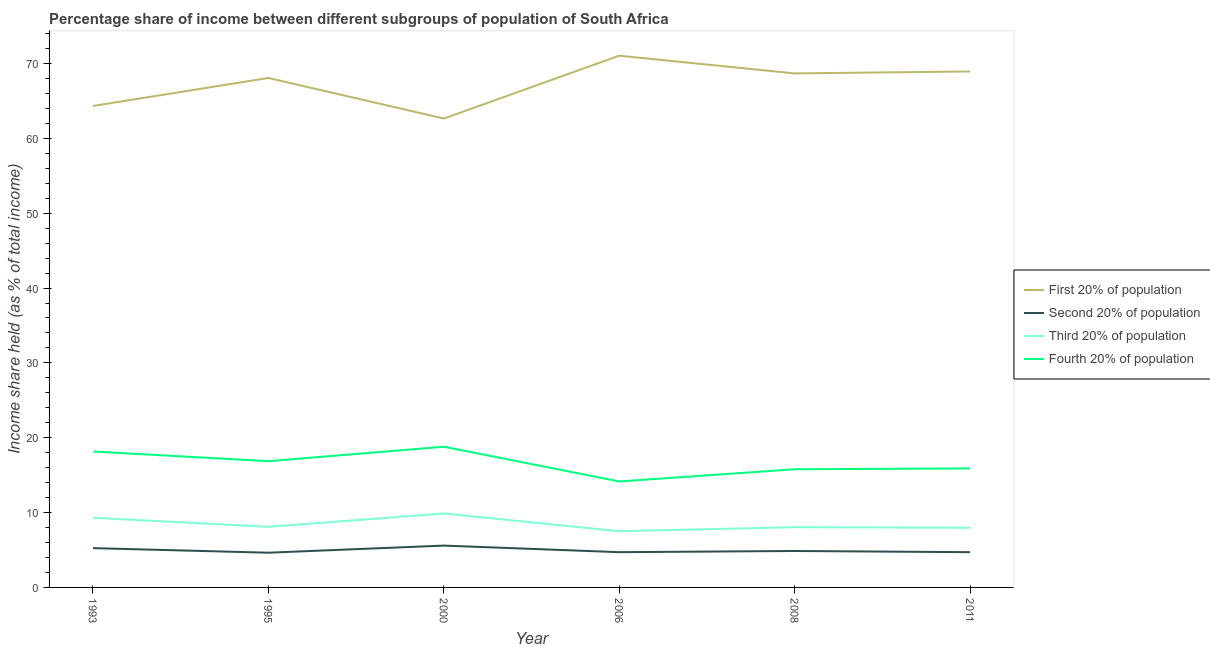Does the line corresponding to share of the income held by second 20% of the population intersect with the line corresponding to share of the income held by first 20% of the population?
Offer a very short reply. No. What is the share of the income held by first 20% of the population in 2011?
Make the answer very short. 68.94. Across all years, what is the maximum share of the income held by third 20% of the population?
Offer a terse response. 9.88. Across all years, what is the minimum share of the income held by third 20% of the population?
Offer a very short reply. 7.51. In which year was the share of the income held by fourth 20% of the population minimum?
Keep it short and to the point. 2006. What is the total share of the income held by third 20% of the population in the graph?
Your response must be concise. 50.82. What is the difference between the share of the income held by second 20% of the population in 2000 and that in 2008?
Your answer should be compact. 0.72. What is the difference between the share of the income held by first 20% of the population in 1995 and the share of the income held by second 20% of the population in 2008?
Offer a very short reply. 63.2. What is the average share of the income held by fourth 20% of the population per year?
Provide a succinct answer. 16.61. In the year 1995, what is the difference between the share of the income held by third 20% of the population and share of the income held by second 20% of the population?
Your response must be concise. 3.46. In how many years, is the share of the income held by second 20% of the population greater than 46 %?
Provide a succinct answer. 0. What is the ratio of the share of the income held by third 20% of the population in 1995 to that in 2011?
Make the answer very short. 1.02. Is the share of the income held by first 20% of the population in 1993 less than that in 2011?
Keep it short and to the point. Yes. What is the difference between the highest and the second highest share of the income held by third 20% of the population?
Your answer should be very brief. 0.57. What is the difference between the highest and the lowest share of the income held by second 20% of the population?
Offer a terse response. 0.95. Is the sum of the share of the income held by fourth 20% of the population in 2000 and 2011 greater than the maximum share of the income held by second 20% of the population across all years?
Provide a short and direct response. Yes. Is it the case that in every year, the sum of the share of the income held by first 20% of the population and share of the income held by second 20% of the population is greater than the share of the income held by third 20% of the population?
Keep it short and to the point. Yes. Is the share of the income held by third 20% of the population strictly greater than the share of the income held by second 20% of the population over the years?
Your answer should be very brief. Yes. How many years are there in the graph?
Your answer should be very brief. 6. How are the legend labels stacked?
Offer a terse response. Vertical. What is the title of the graph?
Your answer should be very brief. Percentage share of income between different subgroups of population of South Africa. What is the label or title of the Y-axis?
Give a very brief answer. Income share held (as % of total income). What is the Income share held (as % of total income) of First 20% of population in 1993?
Make the answer very short. 64.33. What is the Income share held (as % of total income) of Second 20% of population in 1993?
Give a very brief answer. 5.25. What is the Income share held (as % of total income) in Third 20% of population in 1993?
Your answer should be compact. 9.31. What is the Income share held (as % of total income) in Fourth 20% of population in 1993?
Provide a short and direct response. 18.16. What is the Income share held (as % of total income) of First 20% of population in 1995?
Ensure brevity in your answer.  68.07. What is the Income share held (as % of total income) in Second 20% of population in 1995?
Your response must be concise. 4.64. What is the Income share held (as % of total income) of Third 20% of population in 1995?
Keep it short and to the point. 8.1. What is the Income share held (as % of total income) in Fourth 20% of population in 1995?
Keep it short and to the point. 16.87. What is the Income share held (as % of total income) of First 20% of population in 2000?
Your answer should be very brief. 62.65. What is the Income share held (as % of total income) of Second 20% of population in 2000?
Offer a terse response. 5.59. What is the Income share held (as % of total income) of Third 20% of population in 2000?
Provide a short and direct response. 9.88. What is the Income share held (as % of total income) in Fourth 20% of population in 2000?
Make the answer very short. 18.8. What is the Income share held (as % of total income) of First 20% of population in 2006?
Offer a very short reply. 71.05. What is the Income share held (as % of total income) in Second 20% of population in 2006?
Provide a short and direct response. 4.71. What is the Income share held (as % of total income) in Third 20% of population in 2006?
Offer a very short reply. 7.51. What is the Income share held (as % of total income) of Fourth 20% of population in 2006?
Your answer should be compact. 14.16. What is the Income share held (as % of total income) in First 20% of population in 2008?
Provide a short and direct response. 68.68. What is the Income share held (as % of total income) in Second 20% of population in 2008?
Ensure brevity in your answer.  4.87. What is the Income share held (as % of total income) in Third 20% of population in 2008?
Offer a terse response. 8.05. What is the Income share held (as % of total income) in Fourth 20% of population in 2008?
Provide a short and direct response. 15.79. What is the Income share held (as % of total income) of First 20% of population in 2011?
Your response must be concise. 68.94. What is the Income share held (as % of total income) in Second 20% of population in 2011?
Offer a terse response. 4.71. What is the Income share held (as % of total income) of Third 20% of population in 2011?
Keep it short and to the point. 7.97. Across all years, what is the maximum Income share held (as % of total income) in First 20% of population?
Your response must be concise. 71.05. Across all years, what is the maximum Income share held (as % of total income) in Second 20% of population?
Ensure brevity in your answer.  5.59. Across all years, what is the maximum Income share held (as % of total income) in Third 20% of population?
Make the answer very short. 9.88. Across all years, what is the maximum Income share held (as % of total income) in Fourth 20% of population?
Offer a terse response. 18.8. Across all years, what is the minimum Income share held (as % of total income) in First 20% of population?
Ensure brevity in your answer.  62.65. Across all years, what is the minimum Income share held (as % of total income) in Second 20% of population?
Keep it short and to the point. 4.64. Across all years, what is the minimum Income share held (as % of total income) of Third 20% of population?
Your answer should be compact. 7.51. Across all years, what is the minimum Income share held (as % of total income) in Fourth 20% of population?
Keep it short and to the point. 14.16. What is the total Income share held (as % of total income) of First 20% of population in the graph?
Keep it short and to the point. 403.72. What is the total Income share held (as % of total income) in Second 20% of population in the graph?
Your response must be concise. 29.77. What is the total Income share held (as % of total income) in Third 20% of population in the graph?
Provide a short and direct response. 50.82. What is the total Income share held (as % of total income) of Fourth 20% of population in the graph?
Ensure brevity in your answer.  99.68. What is the difference between the Income share held (as % of total income) in First 20% of population in 1993 and that in 1995?
Make the answer very short. -3.74. What is the difference between the Income share held (as % of total income) in Second 20% of population in 1993 and that in 1995?
Offer a very short reply. 0.61. What is the difference between the Income share held (as % of total income) in Third 20% of population in 1993 and that in 1995?
Your answer should be compact. 1.21. What is the difference between the Income share held (as % of total income) in Fourth 20% of population in 1993 and that in 1995?
Make the answer very short. 1.29. What is the difference between the Income share held (as % of total income) in First 20% of population in 1993 and that in 2000?
Give a very brief answer. 1.68. What is the difference between the Income share held (as % of total income) of Second 20% of population in 1993 and that in 2000?
Your answer should be compact. -0.34. What is the difference between the Income share held (as % of total income) in Third 20% of population in 1993 and that in 2000?
Keep it short and to the point. -0.57. What is the difference between the Income share held (as % of total income) of Fourth 20% of population in 1993 and that in 2000?
Offer a very short reply. -0.64. What is the difference between the Income share held (as % of total income) of First 20% of population in 1993 and that in 2006?
Provide a succinct answer. -6.72. What is the difference between the Income share held (as % of total income) of Second 20% of population in 1993 and that in 2006?
Your response must be concise. 0.54. What is the difference between the Income share held (as % of total income) in Fourth 20% of population in 1993 and that in 2006?
Make the answer very short. 4. What is the difference between the Income share held (as % of total income) of First 20% of population in 1993 and that in 2008?
Your response must be concise. -4.35. What is the difference between the Income share held (as % of total income) in Second 20% of population in 1993 and that in 2008?
Give a very brief answer. 0.38. What is the difference between the Income share held (as % of total income) of Third 20% of population in 1993 and that in 2008?
Your response must be concise. 1.26. What is the difference between the Income share held (as % of total income) in Fourth 20% of population in 1993 and that in 2008?
Ensure brevity in your answer.  2.37. What is the difference between the Income share held (as % of total income) of First 20% of population in 1993 and that in 2011?
Give a very brief answer. -4.61. What is the difference between the Income share held (as % of total income) in Second 20% of population in 1993 and that in 2011?
Give a very brief answer. 0.54. What is the difference between the Income share held (as % of total income) of Third 20% of population in 1993 and that in 2011?
Your answer should be very brief. 1.34. What is the difference between the Income share held (as % of total income) of Fourth 20% of population in 1993 and that in 2011?
Provide a short and direct response. 2.26. What is the difference between the Income share held (as % of total income) of First 20% of population in 1995 and that in 2000?
Provide a short and direct response. 5.42. What is the difference between the Income share held (as % of total income) of Second 20% of population in 1995 and that in 2000?
Offer a very short reply. -0.95. What is the difference between the Income share held (as % of total income) in Third 20% of population in 1995 and that in 2000?
Your response must be concise. -1.78. What is the difference between the Income share held (as % of total income) of Fourth 20% of population in 1995 and that in 2000?
Give a very brief answer. -1.93. What is the difference between the Income share held (as % of total income) of First 20% of population in 1995 and that in 2006?
Keep it short and to the point. -2.98. What is the difference between the Income share held (as % of total income) in Second 20% of population in 1995 and that in 2006?
Provide a short and direct response. -0.07. What is the difference between the Income share held (as % of total income) of Third 20% of population in 1995 and that in 2006?
Give a very brief answer. 0.59. What is the difference between the Income share held (as % of total income) in Fourth 20% of population in 1995 and that in 2006?
Your answer should be compact. 2.71. What is the difference between the Income share held (as % of total income) of First 20% of population in 1995 and that in 2008?
Your response must be concise. -0.61. What is the difference between the Income share held (as % of total income) in Second 20% of population in 1995 and that in 2008?
Offer a terse response. -0.23. What is the difference between the Income share held (as % of total income) in Third 20% of population in 1995 and that in 2008?
Ensure brevity in your answer.  0.05. What is the difference between the Income share held (as % of total income) in First 20% of population in 1995 and that in 2011?
Your answer should be compact. -0.87. What is the difference between the Income share held (as % of total income) of Second 20% of population in 1995 and that in 2011?
Keep it short and to the point. -0.07. What is the difference between the Income share held (as % of total income) of Third 20% of population in 1995 and that in 2011?
Provide a succinct answer. 0.13. What is the difference between the Income share held (as % of total income) of Second 20% of population in 2000 and that in 2006?
Provide a succinct answer. 0.88. What is the difference between the Income share held (as % of total income) in Third 20% of population in 2000 and that in 2006?
Your answer should be compact. 2.37. What is the difference between the Income share held (as % of total income) in Fourth 20% of population in 2000 and that in 2006?
Give a very brief answer. 4.64. What is the difference between the Income share held (as % of total income) in First 20% of population in 2000 and that in 2008?
Give a very brief answer. -6.03. What is the difference between the Income share held (as % of total income) in Second 20% of population in 2000 and that in 2008?
Make the answer very short. 0.72. What is the difference between the Income share held (as % of total income) of Third 20% of population in 2000 and that in 2008?
Provide a succinct answer. 1.83. What is the difference between the Income share held (as % of total income) in Fourth 20% of population in 2000 and that in 2008?
Your response must be concise. 3.01. What is the difference between the Income share held (as % of total income) of First 20% of population in 2000 and that in 2011?
Your answer should be very brief. -6.29. What is the difference between the Income share held (as % of total income) in Second 20% of population in 2000 and that in 2011?
Ensure brevity in your answer.  0.88. What is the difference between the Income share held (as % of total income) in Third 20% of population in 2000 and that in 2011?
Keep it short and to the point. 1.91. What is the difference between the Income share held (as % of total income) in Fourth 20% of population in 2000 and that in 2011?
Your answer should be compact. 2.9. What is the difference between the Income share held (as % of total income) of First 20% of population in 2006 and that in 2008?
Your response must be concise. 2.37. What is the difference between the Income share held (as % of total income) of Second 20% of population in 2006 and that in 2008?
Your answer should be very brief. -0.16. What is the difference between the Income share held (as % of total income) of Third 20% of population in 2006 and that in 2008?
Make the answer very short. -0.54. What is the difference between the Income share held (as % of total income) in Fourth 20% of population in 2006 and that in 2008?
Offer a terse response. -1.63. What is the difference between the Income share held (as % of total income) in First 20% of population in 2006 and that in 2011?
Make the answer very short. 2.11. What is the difference between the Income share held (as % of total income) of Third 20% of population in 2006 and that in 2011?
Your answer should be compact. -0.46. What is the difference between the Income share held (as % of total income) in Fourth 20% of population in 2006 and that in 2011?
Provide a short and direct response. -1.74. What is the difference between the Income share held (as % of total income) of First 20% of population in 2008 and that in 2011?
Keep it short and to the point. -0.26. What is the difference between the Income share held (as % of total income) in Second 20% of population in 2008 and that in 2011?
Make the answer very short. 0.16. What is the difference between the Income share held (as % of total income) in Fourth 20% of population in 2008 and that in 2011?
Offer a very short reply. -0.11. What is the difference between the Income share held (as % of total income) of First 20% of population in 1993 and the Income share held (as % of total income) of Second 20% of population in 1995?
Provide a short and direct response. 59.69. What is the difference between the Income share held (as % of total income) in First 20% of population in 1993 and the Income share held (as % of total income) in Third 20% of population in 1995?
Provide a short and direct response. 56.23. What is the difference between the Income share held (as % of total income) of First 20% of population in 1993 and the Income share held (as % of total income) of Fourth 20% of population in 1995?
Offer a terse response. 47.46. What is the difference between the Income share held (as % of total income) in Second 20% of population in 1993 and the Income share held (as % of total income) in Third 20% of population in 1995?
Offer a very short reply. -2.85. What is the difference between the Income share held (as % of total income) in Second 20% of population in 1993 and the Income share held (as % of total income) in Fourth 20% of population in 1995?
Make the answer very short. -11.62. What is the difference between the Income share held (as % of total income) of Third 20% of population in 1993 and the Income share held (as % of total income) of Fourth 20% of population in 1995?
Your response must be concise. -7.56. What is the difference between the Income share held (as % of total income) of First 20% of population in 1993 and the Income share held (as % of total income) of Second 20% of population in 2000?
Offer a terse response. 58.74. What is the difference between the Income share held (as % of total income) in First 20% of population in 1993 and the Income share held (as % of total income) in Third 20% of population in 2000?
Provide a short and direct response. 54.45. What is the difference between the Income share held (as % of total income) in First 20% of population in 1993 and the Income share held (as % of total income) in Fourth 20% of population in 2000?
Give a very brief answer. 45.53. What is the difference between the Income share held (as % of total income) in Second 20% of population in 1993 and the Income share held (as % of total income) in Third 20% of population in 2000?
Keep it short and to the point. -4.63. What is the difference between the Income share held (as % of total income) in Second 20% of population in 1993 and the Income share held (as % of total income) in Fourth 20% of population in 2000?
Your answer should be very brief. -13.55. What is the difference between the Income share held (as % of total income) of Third 20% of population in 1993 and the Income share held (as % of total income) of Fourth 20% of population in 2000?
Your answer should be compact. -9.49. What is the difference between the Income share held (as % of total income) of First 20% of population in 1993 and the Income share held (as % of total income) of Second 20% of population in 2006?
Give a very brief answer. 59.62. What is the difference between the Income share held (as % of total income) in First 20% of population in 1993 and the Income share held (as % of total income) in Third 20% of population in 2006?
Your answer should be very brief. 56.82. What is the difference between the Income share held (as % of total income) of First 20% of population in 1993 and the Income share held (as % of total income) of Fourth 20% of population in 2006?
Your answer should be compact. 50.17. What is the difference between the Income share held (as % of total income) of Second 20% of population in 1993 and the Income share held (as % of total income) of Third 20% of population in 2006?
Provide a short and direct response. -2.26. What is the difference between the Income share held (as % of total income) in Second 20% of population in 1993 and the Income share held (as % of total income) in Fourth 20% of population in 2006?
Your response must be concise. -8.91. What is the difference between the Income share held (as % of total income) in Third 20% of population in 1993 and the Income share held (as % of total income) in Fourth 20% of population in 2006?
Offer a terse response. -4.85. What is the difference between the Income share held (as % of total income) of First 20% of population in 1993 and the Income share held (as % of total income) of Second 20% of population in 2008?
Provide a short and direct response. 59.46. What is the difference between the Income share held (as % of total income) of First 20% of population in 1993 and the Income share held (as % of total income) of Third 20% of population in 2008?
Offer a very short reply. 56.28. What is the difference between the Income share held (as % of total income) of First 20% of population in 1993 and the Income share held (as % of total income) of Fourth 20% of population in 2008?
Offer a very short reply. 48.54. What is the difference between the Income share held (as % of total income) of Second 20% of population in 1993 and the Income share held (as % of total income) of Third 20% of population in 2008?
Your answer should be very brief. -2.8. What is the difference between the Income share held (as % of total income) of Second 20% of population in 1993 and the Income share held (as % of total income) of Fourth 20% of population in 2008?
Your response must be concise. -10.54. What is the difference between the Income share held (as % of total income) in Third 20% of population in 1993 and the Income share held (as % of total income) in Fourth 20% of population in 2008?
Offer a terse response. -6.48. What is the difference between the Income share held (as % of total income) of First 20% of population in 1993 and the Income share held (as % of total income) of Second 20% of population in 2011?
Provide a succinct answer. 59.62. What is the difference between the Income share held (as % of total income) of First 20% of population in 1993 and the Income share held (as % of total income) of Third 20% of population in 2011?
Offer a very short reply. 56.36. What is the difference between the Income share held (as % of total income) of First 20% of population in 1993 and the Income share held (as % of total income) of Fourth 20% of population in 2011?
Offer a very short reply. 48.43. What is the difference between the Income share held (as % of total income) in Second 20% of population in 1993 and the Income share held (as % of total income) in Third 20% of population in 2011?
Provide a succinct answer. -2.72. What is the difference between the Income share held (as % of total income) of Second 20% of population in 1993 and the Income share held (as % of total income) of Fourth 20% of population in 2011?
Your answer should be very brief. -10.65. What is the difference between the Income share held (as % of total income) in Third 20% of population in 1993 and the Income share held (as % of total income) in Fourth 20% of population in 2011?
Keep it short and to the point. -6.59. What is the difference between the Income share held (as % of total income) of First 20% of population in 1995 and the Income share held (as % of total income) of Second 20% of population in 2000?
Offer a terse response. 62.48. What is the difference between the Income share held (as % of total income) in First 20% of population in 1995 and the Income share held (as % of total income) in Third 20% of population in 2000?
Provide a succinct answer. 58.19. What is the difference between the Income share held (as % of total income) of First 20% of population in 1995 and the Income share held (as % of total income) of Fourth 20% of population in 2000?
Your answer should be compact. 49.27. What is the difference between the Income share held (as % of total income) in Second 20% of population in 1995 and the Income share held (as % of total income) in Third 20% of population in 2000?
Ensure brevity in your answer.  -5.24. What is the difference between the Income share held (as % of total income) of Second 20% of population in 1995 and the Income share held (as % of total income) of Fourth 20% of population in 2000?
Provide a short and direct response. -14.16. What is the difference between the Income share held (as % of total income) in First 20% of population in 1995 and the Income share held (as % of total income) in Second 20% of population in 2006?
Provide a short and direct response. 63.36. What is the difference between the Income share held (as % of total income) in First 20% of population in 1995 and the Income share held (as % of total income) in Third 20% of population in 2006?
Offer a very short reply. 60.56. What is the difference between the Income share held (as % of total income) in First 20% of population in 1995 and the Income share held (as % of total income) in Fourth 20% of population in 2006?
Your answer should be very brief. 53.91. What is the difference between the Income share held (as % of total income) in Second 20% of population in 1995 and the Income share held (as % of total income) in Third 20% of population in 2006?
Ensure brevity in your answer.  -2.87. What is the difference between the Income share held (as % of total income) of Second 20% of population in 1995 and the Income share held (as % of total income) of Fourth 20% of population in 2006?
Make the answer very short. -9.52. What is the difference between the Income share held (as % of total income) of Third 20% of population in 1995 and the Income share held (as % of total income) of Fourth 20% of population in 2006?
Provide a succinct answer. -6.06. What is the difference between the Income share held (as % of total income) of First 20% of population in 1995 and the Income share held (as % of total income) of Second 20% of population in 2008?
Offer a terse response. 63.2. What is the difference between the Income share held (as % of total income) in First 20% of population in 1995 and the Income share held (as % of total income) in Third 20% of population in 2008?
Keep it short and to the point. 60.02. What is the difference between the Income share held (as % of total income) in First 20% of population in 1995 and the Income share held (as % of total income) in Fourth 20% of population in 2008?
Your answer should be compact. 52.28. What is the difference between the Income share held (as % of total income) of Second 20% of population in 1995 and the Income share held (as % of total income) of Third 20% of population in 2008?
Your answer should be very brief. -3.41. What is the difference between the Income share held (as % of total income) of Second 20% of population in 1995 and the Income share held (as % of total income) of Fourth 20% of population in 2008?
Offer a terse response. -11.15. What is the difference between the Income share held (as % of total income) in Third 20% of population in 1995 and the Income share held (as % of total income) in Fourth 20% of population in 2008?
Give a very brief answer. -7.69. What is the difference between the Income share held (as % of total income) of First 20% of population in 1995 and the Income share held (as % of total income) of Second 20% of population in 2011?
Keep it short and to the point. 63.36. What is the difference between the Income share held (as % of total income) of First 20% of population in 1995 and the Income share held (as % of total income) of Third 20% of population in 2011?
Keep it short and to the point. 60.1. What is the difference between the Income share held (as % of total income) of First 20% of population in 1995 and the Income share held (as % of total income) of Fourth 20% of population in 2011?
Your answer should be very brief. 52.17. What is the difference between the Income share held (as % of total income) of Second 20% of population in 1995 and the Income share held (as % of total income) of Third 20% of population in 2011?
Ensure brevity in your answer.  -3.33. What is the difference between the Income share held (as % of total income) of Second 20% of population in 1995 and the Income share held (as % of total income) of Fourth 20% of population in 2011?
Keep it short and to the point. -11.26. What is the difference between the Income share held (as % of total income) of First 20% of population in 2000 and the Income share held (as % of total income) of Second 20% of population in 2006?
Make the answer very short. 57.94. What is the difference between the Income share held (as % of total income) in First 20% of population in 2000 and the Income share held (as % of total income) in Third 20% of population in 2006?
Your answer should be very brief. 55.14. What is the difference between the Income share held (as % of total income) of First 20% of population in 2000 and the Income share held (as % of total income) of Fourth 20% of population in 2006?
Your answer should be compact. 48.49. What is the difference between the Income share held (as % of total income) in Second 20% of population in 2000 and the Income share held (as % of total income) in Third 20% of population in 2006?
Your answer should be very brief. -1.92. What is the difference between the Income share held (as % of total income) in Second 20% of population in 2000 and the Income share held (as % of total income) in Fourth 20% of population in 2006?
Your answer should be compact. -8.57. What is the difference between the Income share held (as % of total income) in Third 20% of population in 2000 and the Income share held (as % of total income) in Fourth 20% of population in 2006?
Your answer should be compact. -4.28. What is the difference between the Income share held (as % of total income) in First 20% of population in 2000 and the Income share held (as % of total income) in Second 20% of population in 2008?
Keep it short and to the point. 57.78. What is the difference between the Income share held (as % of total income) in First 20% of population in 2000 and the Income share held (as % of total income) in Third 20% of population in 2008?
Your answer should be compact. 54.6. What is the difference between the Income share held (as % of total income) of First 20% of population in 2000 and the Income share held (as % of total income) of Fourth 20% of population in 2008?
Provide a short and direct response. 46.86. What is the difference between the Income share held (as % of total income) of Second 20% of population in 2000 and the Income share held (as % of total income) of Third 20% of population in 2008?
Offer a terse response. -2.46. What is the difference between the Income share held (as % of total income) of Second 20% of population in 2000 and the Income share held (as % of total income) of Fourth 20% of population in 2008?
Offer a very short reply. -10.2. What is the difference between the Income share held (as % of total income) of Third 20% of population in 2000 and the Income share held (as % of total income) of Fourth 20% of population in 2008?
Make the answer very short. -5.91. What is the difference between the Income share held (as % of total income) of First 20% of population in 2000 and the Income share held (as % of total income) of Second 20% of population in 2011?
Provide a succinct answer. 57.94. What is the difference between the Income share held (as % of total income) in First 20% of population in 2000 and the Income share held (as % of total income) in Third 20% of population in 2011?
Offer a very short reply. 54.68. What is the difference between the Income share held (as % of total income) of First 20% of population in 2000 and the Income share held (as % of total income) of Fourth 20% of population in 2011?
Keep it short and to the point. 46.75. What is the difference between the Income share held (as % of total income) in Second 20% of population in 2000 and the Income share held (as % of total income) in Third 20% of population in 2011?
Your answer should be compact. -2.38. What is the difference between the Income share held (as % of total income) in Second 20% of population in 2000 and the Income share held (as % of total income) in Fourth 20% of population in 2011?
Keep it short and to the point. -10.31. What is the difference between the Income share held (as % of total income) in Third 20% of population in 2000 and the Income share held (as % of total income) in Fourth 20% of population in 2011?
Your answer should be compact. -6.02. What is the difference between the Income share held (as % of total income) in First 20% of population in 2006 and the Income share held (as % of total income) in Second 20% of population in 2008?
Your answer should be very brief. 66.18. What is the difference between the Income share held (as % of total income) in First 20% of population in 2006 and the Income share held (as % of total income) in Third 20% of population in 2008?
Keep it short and to the point. 63. What is the difference between the Income share held (as % of total income) of First 20% of population in 2006 and the Income share held (as % of total income) of Fourth 20% of population in 2008?
Keep it short and to the point. 55.26. What is the difference between the Income share held (as % of total income) in Second 20% of population in 2006 and the Income share held (as % of total income) in Third 20% of population in 2008?
Provide a short and direct response. -3.34. What is the difference between the Income share held (as % of total income) in Second 20% of population in 2006 and the Income share held (as % of total income) in Fourth 20% of population in 2008?
Your answer should be compact. -11.08. What is the difference between the Income share held (as % of total income) of Third 20% of population in 2006 and the Income share held (as % of total income) of Fourth 20% of population in 2008?
Your answer should be very brief. -8.28. What is the difference between the Income share held (as % of total income) in First 20% of population in 2006 and the Income share held (as % of total income) in Second 20% of population in 2011?
Your answer should be compact. 66.34. What is the difference between the Income share held (as % of total income) in First 20% of population in 2006 and the Income share held (as % of total income) in Third 20% of population in 2011?
Your answer should be very brief. 63.08. What is the difference between the Income share held (as % of total income) in First 20% of population in 2006 and the Income share held (as % of total income) in Fourth 20% of population in 2011?
Keep it short and to the point. 55.15. What is the difference between the Income share held (as % of total income) of Second 20% of population in 2006 and the Income share held (as % of total income) of Third 20% of population in 2011?
Ensure brevity in your answer.  -3.26. What is the difference between the Income share held (as % of total income) of Second 20% of population in 2006 and the Income share held (as % of total income) of Fourth 20% of population in 2011?
Provide a succinct answer. -11.19. What is the difference between the Income share held (as % of total income) in Third 20% of population in 2006 and the Income share held (as % of total income) in Fourth 20% of population in 2011?
Provide a short and direct response. -8.39. What is the difference between the Income share held (as % of total income) of First 20% of population in 2008 and the Income share held (as % of total income) of Second 20% of population in 2011?
Your answer should be compact. 63.97. What is the difference between the Income share held (as % of total income) of First 20% of population in 2008 and the Income share held (as % of total income) of Third 20% of population in 2011?
Ensure brevity in your answer.  60.71. What is the difference between the Income share held (as % of total income) in First 20% of population in 2008 and the Income share held (as % of total income) in Fourth 20% of population in 2011?
Your answer should be compact. 52.78. What is the difference between the Income share held (as % of total income) of Second 20% of population in 2008 and the Income share held (as % of total income) of Third 20% of population in 2011?
Make the answer very short. -3.1. What is the difference between the Income share held (as % of total income) of Second 20% of population in 2008 and the Income share held (as % of total income) of Fourth 20% of population in 2011?
Your answer should be very brief. -11.03. What is the difference between the Income share held (as % of total income) in Third 20% of population in 2008 and the Income share held (as % of total income) in Fourth 20% of population in 2011?
Offer a terse response. -7.85. What is the average Income share held (as % of total income) in First 20% of population per year?
Your response must be concise. 67.29. What is the average Income share held (as % of total income) of Second 20% of population per year?
Your answer should be very brief. 4.96. What is the average Income share held (as % of total income) of Third 20% of population per year?
Offer a terse response. 8.47. What is the average Income share held (as % of total income) in Fourth 20% of population per year?
Keep it short and to the point. 16.61. In the year 1993, what is the difference between the Income share held (as % of total income) of First 20% of population and Income share held (as % of total income) of Second 20% of population?
Your answer should be compact. 59.08. In the year 1993, what is the difference between the Income share held (as % of total income) in First 20% of population and Income share held (as % of total income) in Third 20% of population?
Make the answer very short. 55.02. In the year 1993, what is the difference between the Income share held (as % of total income) in First 20% of population and Income share held (as % of total income) in Fourth 20% of population?
Your answer should be very brief. 46.17. In the year 1993, what is the difference between the Income share held (as % of total income) of Second 20% of population and Income share held (as % of total income) of Third 20% of population?
Give a very brief answer. -4.06. In the year 1993, what is the difference between the Income share held (as % of total income) in Second 20% of population and Income share held (as % of total income) in Fourth 20% of population?
Make the answer very short. -12.91. In the year 1993, what is the difference between the Income share held (as % of total income) of Third 20% of population and Income share held (as % of total income) of Fourth 20% of population?
Offer a terse response. -8.85. In the year 1995, what is the difference between the Income share held (as % of total income) of First 20% of population and Income share held (as % of total income) of Second 20% of population?
Offer a very short reply. 63.43. In the year 1995, what is the difference between the Income share held (as % of total income) in First 20% of population and Income share held (as % of total income) in Third 20% of population?
Provide a short and direct response. 59.97. In the year 1995, what is the difference between the Income share held (as % of total income) in First 20% of population and Income share held (as % of total income) in Fourth 20% of population?
Provide a short and direct response. 51.2. In the year 1995, what is the difference between the Income share held (as % of total income) in Second 20% of population and Income share held (as % of total income) in Third 20% of population?
Make the answer very short. -3.46. In the year 1995, what is the difference between the Income share held (as % of total income) in Second 20% of population and Income share held (as % of total income) in Fourth 20% of population?
Make the answer very short. -12.23. In the year 1995, what is the difference between the Income share held (as % of total income) in Third 20% of population and Income share held (as % of total income) in Fourth 20% of population?
Ensure brevity in your answer.  -8.77. In the year 2000, what is the difference between the Income share held (as % of total income) in First 20% of population and Income share held (as % of total income) in Second 20% of population?
Provide a succinct answer. 57.06. In the year 2000, what is the difference between the Income share held (as % of total income) of First 20% of population and Income share held (as % of total income) of Third 20% of population?
Provide a short and direct response. 52.77. In the year 2000, what is the difference between the Income share held (as % of total income) of First 20% of population and Income share held (as % of total income) of Fourth 20% of population?
Provide a succinct answer. 43.85. In the year 2000, what is the difference between the Income share held (as % of total income) in Second 20% of population and Income share held (as % of total income) in Third 20% of population?
Provide a short and direct response. -4.29. In the year 2000, what is the difference between the Income share held (as % of total income) in Second 20% of population and Income share held (as % of total income) in Fourth 20% of population?
Make the answer very short. -13.21. In the year 2000, what is the difference between the Income share held (as % of total income) of Third 20% of population and Income share held (as % of total income) of Fourth 20% of population?
Ensure brevity in your answer.  -8.92. In the year 2006, what is the difference between the Income share held (as % of total income) of First 20% of population and Income share held (as % of total income) of Second 20% of population?
Offer a very short reply. 66.34. In the year 2006, what is the difference between the Income share held (as % of total income) in First 20% of population and Income share held (as % of total income) in Third 20% of population?
Offer a very short reply. 63.54. In the year 2006, what is the difference between the Income share held (as % of total income) in First 20% of population and Income share held (as % of total income) in Fourth 20% of population?
Make the answer very short. 56.89. In the year 2006, what is the difference between the Income share held (as % of total income) in Second 20% of population and Income share held (as % of total income) in Third 20% of population?
Provide a short and direct response. -2.8. In the year 2006, what is the difference between the Income share held (as % of total income) of Second 20% of population and Income share held (as % of total income) of Fourth 20% of population?
Your response must be concise. -9.45. In the year 2006, what is the difference between the Income share held (as % of total income) of Third 20% of population and Income share held (as % of total income) of Fourth 20% of population?
Your answer should be compact. -6.65. In the year 2008, what is the difference between the Income share held (as % of total income) in First 20% of population and Income share held (as % of total income) in Second 20% of population?
Your answer should be very brief. 63.81. In the year 2008, what is the difference between the Income share held (as % of total income) of First 20% of population and Income share held (as % of total income) of Third 20% of population?
Provide a succinct answer. 60.63. In the year 2008, what is the difference between the Income share held (as % of total income) of First 20% of population and Income share held (as % of total income) of Fourth 20% of population?
Ensure brevity in your answer.  52.89. In the year 2008, what is the difference between the Income share held (as % of total income) of Second 20% of population and Income share held (as % of total income) of Third 20% of population?
Your answer should be compact. -3.18. In the year 2008, what is the difference between the Income share held (as % of total income) in Second 20% of population and Income share held (as % of total income) in Fourth 20% of population?
Ensure brevity in your answer.  -10.92. In the year 2008, what is the difference between the Income share held (as % of total income) in Third 20% of population and Income share held (as % of total income) in Fourth 20% of population?
Your answer should be compact. -7.74. In the year 2011, what is the difference between the Income share held (as % of total income) of First 20% of population and Income share held (as % of total income) of Second 20% of population?
Give a very brief answer. 64.23. In the year 2011, what is the difference between the Income share held (as % of total income) of First 20% of population and Income share held (as % of total income) of Third 20% of population?
Keep it short and to the point. 60.97. In the year 2011, what is the difference between the Income share held (as % of total income) of First 20% of population and Income share held (as % of total income) of Fourth 20% of population?
Keep it short and to the point. 53.04. In the year 2011, what is the difference between the Income share held (as % of total income) in Second 20% of population and Income share held (as % of total income) in Third 20% of population?
Ensure brevity in your answer.  -3.26. In the year 2011, what is the difference between the Income share held (as % of total income) in Second 20% of population and Income share held (as % of total income) in Fourth 20% of population?
Give a very brief answer. -11.19. In the year 2011, what is the difference between the Income share held (as % of total income) in Third 20% of population and Income share held (as % of total income) in Fourth 20% of population?
Offer a very short reply. -7.93. What is the ratio of the Income share held (as % of total income) of First 20% of population in 1993 to that in 1995?
Provide a succinct answer. 0.95. What is the ratio of the Income share held (as % of total income) in Second 20% of population in 1993 to that in 1995?
Provide a short and direct response. 1.13. What is the ratio of the Income share held (as % of total income) in Third 20% of population in 1993 to that in 1995?
Your answer should be very brief. 1.15. What is the ratio of the Income share held (as % of total income) in Fourth 20% of population in 1993 to that in 1995?
Your answer should be very brief. 1.08. What is the ratio of the Income share held (as % of total income) of First 20% of population in 1993 to that in 2000?
Offer a terse response. 1.03. What is the ratio of the Income share held (as % of total income) of Second 20% of population in 1993 to that in 2000?
Your response must be concise. 0.94. What is the ratio of the Income share held (as % of total income) in Third 20% of population in 1993 to that in 2000?
Make the answer very short. 0.94. What is the ratio of the Income share held (as % of total income) of First 20% of population in 1993 to that in 2006?
Provide a short and direct response. 0.91. What is the ratio of the Income share held (as % of total income) of Second 20% of population in 1993 to that in 2006?
Keep it short and to the point. 1.11. What is the ratio of the Income share held (as % of total income) of Third 20% of population in 1993 to that in 2006?
Your answer should be compact. 1.24. What is the ratio of the Income share held (as % of total income) of Fourth 20% of population in 1993 to that in 2006?
Provide a short and direct response. 1.28. What is the ratio of the Income share held (as % of total income) in First 20% of population in 1993 to that in 2008?
Provide a succinct answer. 0.94. What is the ratio of the Income share held (as % of total income) of Second 20% of population in 1993 to that in 2008?
Give a very brief answer. 1.08. What is the ratio of the Income share held (as % of total income) of Third 20% of population in 1993 to that in 2008?
Your response must be concise. 1.16. What is the ratio of the Income share held (as % of total income) in Fourth 20% of population in 1993 to that in 2008?
Make the answer very short. 1.15. What is the ratio of the Income share held (as % of total income) in First 20% of population in 1993 to that in 2011?
Offer a terse response. 0.93. What is the ratio of the Income share held (as % of total income) in Second 20% of population in 1993 to that in 2011?
Ensure brevity in your answer.  1.11. What is the ratio of the Income share held (as % of total income) in Third 20% of population in 1993 to that in 2011?
Make the answer very short. 1.17. What is the ratio of the Income share held (as % of total income) of Fourth 20% of population in 1993 to that in 2011?
Make the answer very short. 1.14. What is the ratio of the Income share held (as % of total income) in First 20% of population in 1995 to that in 2000?
Offer a terse response. 1.09. What is the ratio of the Income share held (as % of total income) in Second 20% of population in 1995 to that in 2000?
Make the answer very short. 0.83. What is the ratio of the Income share held (as % of total income) of Third 20% of population in 1995 to that in 2000?
Provide a short and direct response. 0.82. What is the ratio of the Income share held (as % of total income) of Fourth 20% of population in 1995 to that in 2000?
Provide a succinct answer. 0.9. What is the ratio of the Income share held (as % of total income) of First 20% of population in 1995 to that in 2006?
Keep it short and to the point. 0.96. What is the ratio of the Income share held (as % of total income) in Second 20% of population in 1995 to that in 2006?
Ensure brevity in your answer.  0.99. What is the ratio of the Income share held (as % of total income) in Third 20% of population in 1995 to that in 2006?
Ensure brevity in your answer.  1.08. What is the ratio of the Income share held (as % of total income) in Fourth 20% of population in 1995 to that in 2006?
Give a very brief answer. 1.19. What is the ratio of the Income share held (as % of total income) in Second 20% of population in 1995 to that in 2008?
Your answer should be very brief. 0.95. What is the ratio of the Income share held (as % of total income) in Fourth 20% of population in 1995 to that in 2008?
Make the answer very short. 1.07. What is the ratio of the Income share held (as % of total income) of First 20% of population in 1995 to that in 2011?
Give a very brief answer. 0.99. What is the ratio of the Income share held (as % of total income) in Second 20% of population in 1995 to that in 2011?
Make the answer very short. 0.99. What is the ratio of the Income share held (as % of total income) in Third 20% of population in 1995 to that in 2011?
Your response must be concise. 1.02. What is the ratio of the Income share held (as % of total income) in Fourth 20% of population in 1995 to that in 2011?
Provide a short and direct response. 1.06. What is the ratio of the Income share held (as % of total income) of First 20% of population in 2000 to that in 2006?
Give a very brief answer. 0.88. What is the ratio of the Income share held (as % of total income) of Second 20% of population in 2000 to that in 2006?
Your response must be concise. 1.19. What is the ratio of the Income share held (as % of total income) of Third 20% of population in 2000 to that in 2006?
Keep it short and to the point. 1.32. What is the ratio of the Income share held (as % of total income) of Fourth 20% of population in 2000 to that in 2006?
Provide a short and direct response. 1.33. What is the ratio of the Income share held (as % of total income) of First 20% of population in 2000 to that in 2008?
Your response must be concise. 0.91. What is the ratio of the Income share held (as % of total income) in Second 20% of population in 2000 to that in 2008?
Give a very brief answer. 1.15. What is the ratio of the Income share held (as % of total income) of Third 20% of population in 2000 to that in 2008?
Ensure brevity in your answer.  1.23. What is the ratio of the Income share held (as % of total income) in Fourth 20% of population in 2000 to that in 2008?
Ensure brevity in your answer.  1.19. What is the ratio of the Income share held (as % of total income) in First 20% of population in 2000 to that in 2011?
Your answer should be compact. 0.91. What is the ratio of the Income share held (as % of total income) in Second 20% of population in 2000 to that in 2011?
Keep it short and to the point. 1.19. What is the ratio of the Income share held (as % of total income) in Third 20% of population in 2000 to that in 2011?
Your response must be concise. 1.24. What is the ratio of the Income share held (as % of total income) in Fourth 20% of population in 2000 to that in 2011?
Your response must be concise. 1.18. What is the ratio of the Income share held (as % of total income) in First 20% of population in 2006 to that in 2008?
Make the answer very short. 1.03. What is the ratio of the Income share held (as % of total income) of Second 20% of population in 2006 to that in 2008?
Your answer should be compact. 0.97. What is the ratio of the Income share held (as % of total income) in Third 20% of population in 2006 to that in 2008?
Keep it short and to the point. 0.93. What is the ratio of the Income share held (as % of total income) of Fourth 20% of population in 2006 to that in 2008?
Keep it short and to the point. 0.9. What is the ratio of the Income share held (as % of total income) in First 20% of population in 2006 to that in 2011?
Give a very brief answer. 1.03. What is the ratio of the Income share held (as % of total income) of Second 20% of population in 2006 to that in 2011?
Keep it short and to the point. 1. What is the ratio of the Income share held (as % of total income) in Third 20% of population in 2006 to that in 2011?
Give a very brief answer. 0.94. What is the ratio of the Income share held (as % of total income) in Fourth 20% of population in 2006 to that in 2011?
Your response must be concise. 0.89. What is the ratio of the Income share held (as % of total income) of Second 20% of population in 2008 to that in 2011?
Provide a succinct answer. 1.03. What is the ratio of the Income share held (as % of total income) in Fourth 20% of population in 2008 to that in 2011?
Give a very brief answer. 0.99. What is the difference between the highest and the second highest Income share held (as % of total income) in First 20% of population?
Offer a terse response. 2.11. What is the difference between the highest and the second highest Income share held (as % of total income) of Second 20% of population?
Keep it short and to the point. 0.34. What is the difference between the highest and the second highest Income share held (as % of total income) in Third 20% of population?
Offer a very short reply. 0.57. What is the difference between the highest and the second highest Income share held (as % of total income) in Fourth 20% of population?
Your response must be concise. 0.64. What is the difference between the highest and the lowest Income share held (as % of total income) of Second 20% of population?
Provide a succinct answer. 0.95. What is the difference between the highest and the lowest Income share held (as % of total income) of Third 20% of population?
Offer a very short reply. 2.37. What is the difference between the highest and the lowest Income share held (as % of total income) of Fourth 20% of population?
Provide a succinct answer. 4.64. 